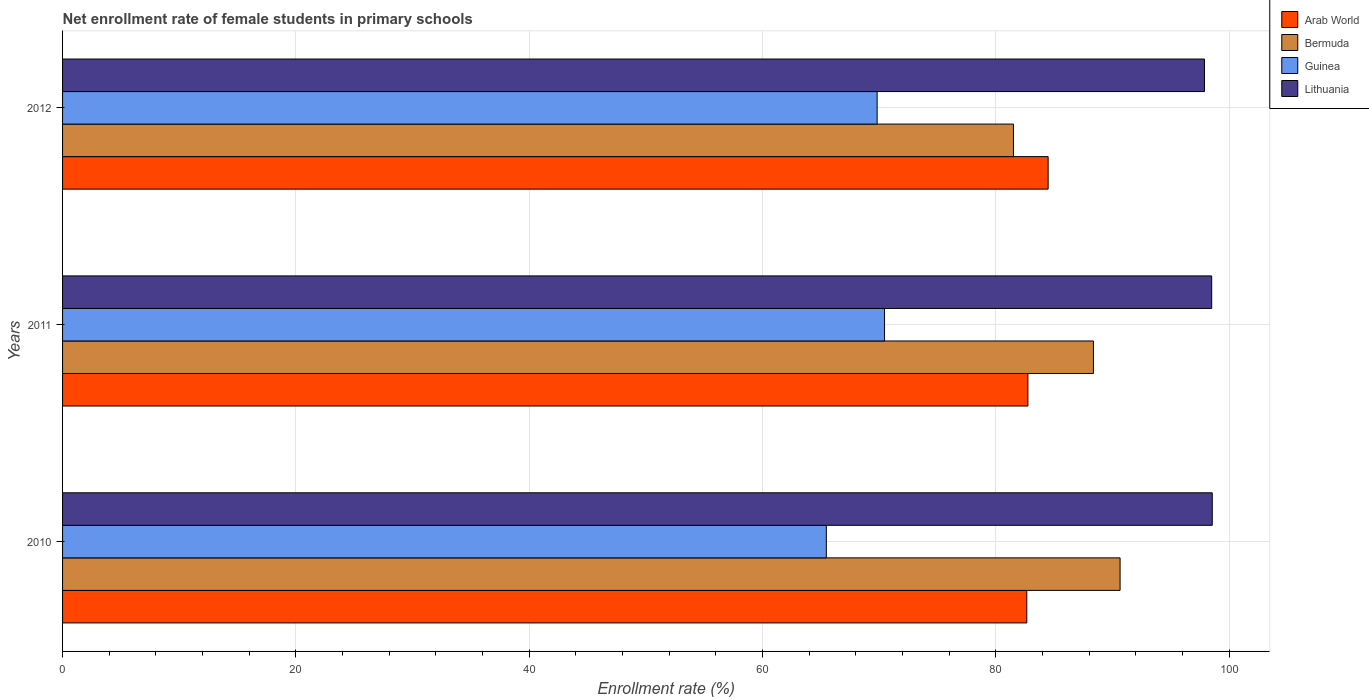In how many cases, is the number of bars for a given year not equal to the number of legend labels?
Your answer should be compact. 0. What is the net enrollment rate of female students in primary schools in Guinea in 2012?
Make the answer very short. 69.82. Across all years, what is the maximum net enrollment rate of female students in primary schools in Bermuda?
Provide a succinct answer. 90.64. Across all years, what is the minimum net enrollment rate of female students in primary schools in Guinea?
Your answer should be compact. 65.46. In which year was the net enrollment rate of female students in primary schools in Lithuania maximum?
Offer a very short reply. 2010. What is the total net enrollment rate of female students in primary schools in Arab World in the graph?
Keep it short and to the point. 249.86. What is the difference between the net enrollment rate of female students in primary schools in Lithuania in 2011 and that in 2012?
Provide a succinct answer. 0.62. What is the difference between the net enrollment rate of female students in primary schools in Lithuania in 2010 and the net enrollment rate of female students in primary schools in Guinea in 2011?
Your answer should be compact. 28.09. What is the average net enrollment rate of female students in primary schools in Arab World per year?
Provide a short and direct response. 83.29. In the year 2010, what is the difference between the net enrollment rate of female students in primary schools in Bermuda and net enrollment rate of female students in primary schools in Guinea?
Your response must be concise. 25.18. In how many years, is the net enrollment rate of female students in primary schools in Arab World greater than 60 %?
Keep it short and to the point. 3. What is the ratio of the net enrollment rate of female students in primary schools in Lithuania in 2011 to that in 2012?
Make the answer very short. 1.01. What is the difference between the highest and the second highest net enrollment rate of female students in primary schools in Arab World?
Your response must be concise. 1.73. What is the difference between the highest and the lowest net enrollment rate of female students in primary schools in Lithuania?
Provide a short and direct response. 0.67. Is the sum of the net enrollment rate of female students in primary schools in Lithuania in 2011 and 2012 greater than the maximum net enrollment rate of female students in primary schools in Arab World across all years?
Ensure brevity in your answer.  Yes. What does the 1st bar from the top in 2012 represents?
Offer a terse response. Lithuania. What does the 4th bar from the bottom in 2010 represents?
Give a very brief answer. Lithuania. Is it the case that in every year, the sum of the net enrollment rate of female students in primary schools in Arab World and net enrollment rate of female students in primary schools in Guinea is greater than the net enrollment rate of female students in primary schools in Bermuda?
Offer a very short reply. Yes. What is the difference between two consecutive major ticks on the X-axis?
Make the answer very short. 20. Does the graph contain any zero values?
Offer a terse response. No. Where does the legend appear in the graph?
Offer a very short reply. Top right. How are the legend labels stacked?
Your answer should be compact. Vertical. What is the title of the graph?
Make the answer very short. Net enrollment rate of female students in primary schools. What is the label or title of the X-axis?
Ensure brevity in your answer.  Enrollment rate (%). What is the label or title of the Y-axis?
Keep it short and to the point. Years. What is the Enrollment rate (%) of Arab World in 2010?
Your answer should be very brief. 82.65. What is the Enrollment rate (%) of Bermuda in 2010?
Ensure brevity in your answer.  90.64. What is the Enrollment rate (%) of Guinea in 2010?
Your answer should be very brief. 65.46. What is the Enrollment rate (%) of Lithuania in 2010?
Offer a terse response. 98.54. What is the Enrollment rate (%) in Arab World in 2011?
Provide a short and direct response. 82.74. What is the Enrollment rate (%) in Bermuda in 2011?
Your response must be concise. 88.36. What is the Enrollment rate (%) of Guinea in 2011?
Make the answer very short. 70.45. What is the Enrollment rate (%) of Lithuania in 2011?
Provide a succinct answer. 98.49. What is the Enrollment rate (%) of Arab World in 2012?
Provide a succinct answer. 84.48. What is the Enrollment rate (%) of Bermuda in 2012?
Ensure brevity in your answer.  81.5. What is the Enrollment rate (%) in Guinea in 2012?
Give a very brief answer. 69.82. What is the Enrollment rate (%) in Lithuania in 2012?
Give a very brief answer. 97.88. Across all years, what is the maximum Enrollment rate (%) of Arab World?
Ensure brevity in your answer.  84.48. Across all years, what is the maximum Enrollment rate (%) of Bermuda?
Provide a short and direct response. 90.64. Across all years, what is the maximum Enrollment rate (%) in Guinea?
Offer a very short reply. 70.45. Across all years, what is the maximum Enrollment rate (%) in Lithuania?
Your response must be concise. 98.54. Across all years, what is the minimum Enrollment rate (%) of Arab World?
Give a very brief answer. 82.65. Across all years, what is the minimum Enrollment rate (%) of Bermuda?
Ensure brevity in your answer.  81.5. Across all years, what is the minimum Enrollment rate (%) in Guinea?
Keep it short and to the point. 65.46. Across all years, what is the minimum Enrollment rate (%) of Lithuania?
Ensure brevity in your answer.  97.88. What is the total Enrollment rate (%) in Arab World in the graph?
Ensure brevity in your answer.  249.86. What is the total Enrollment rate (%) of Bermuda in the graph?
Offer a very short reply. 260.5. What is the total Enrollment rate (%) in Guinea in the graph?
Your answer should be compact. 205.73. What is the total Enrollment rate (%) in Lithuania in the graph?
Offer a terse response. 294.91. What is the difference between the Enrollment rate (%) in Arab World in 2010 and that in 2011?
Give a very brief answer. -0.09. What is the difference between the Enrollment rate (%) of Bermuda in 2010 and that in 2011?
Offer a very short reply. 2.29. What is the difference between the Enrollment rate (%) of Guinea in 2010 and that in 2011?
Your answer should be very brief. -4.99. What is the difference between the Enrollment rate (%) in Lithuania in 2010 and that in 2011?
Offer a terse response. 0.05. What is the difference between the Enrollment rate (%) of Arab World in 2010 and that in 2012?
Offer a terse response. -1.83. What is the difference between the Enrollment rate (%) of Bermuda in 2010 and that in 2012?
Provide a succinct answer. 9.14. What is the difference between the Enrollment rate (%) of Guinea in 2010 and that in 2012?
Offer a terse response. -4.36. What is the difference between the Enrollment rate (%) in Lithuania in 2010 and that in 2012?
Give a very brief answer. 0.67. What is the difference between the Enrollment rate (%) in Arab World in 2011 and that in 2012?
Your answer should be compact. -1.73. What is the difference between the Enrollment rate (%) in Bermuda in 2011 and that in 2012?
Your answer should be compact. 6.85. What is the difference between the Enrollment rate (%) of Guinea in 2011 and that in 2012?
Your answer should be very brief. 0.63. What is the difference between the Enrollment rate (%) of Lithuania in 2011 and that in 2012?
Your answer should be very brief. 0.62. What is the difference between the Enrollment rate (%) of Arab World in 2010 and the Enrollment rate (%) of Bermuda in 2011?
Make the answer very short. -5.71. What is the difference between the Enrollment rate (%) in Arab World in 2010 and the Enrollment rate (%) in Guinea in 2011?
Make the answer very short. 12.19. What is the difference between the Enrollment rate (%) of Arab World in 2010 and the Enrollment rate (%) of Lithuania in 2011?
Make the answer very short. -15.85. What is the difference between the Enrollment rate (%) of Bermuda in 2010 and the Enrollment rate (%) of Guinea in 2011?
Your answer should be very brief. 20.19. What is the difference between the Enrollment rate (%) in Bermuda in 2010 and the Enrollment rate (%) in Lithuania in 2011?
Your answer should be compact. -7.85. What is the difference between the Enrollment rate (%) in Guinea in 2010 and the Enrollment rate (%) in Lithuania in 2011?
Make the answer very short. -33.03. What is the difference between the Enrollment rate (%) of Arab World in 2010 and the Enrollment rate (%) of Bermuda in 2012?
Give a very brief answer. 1.14. What is the difference between the Enrollment rate (%) of Arab World in 2010 and the Enrollment rate (%) of Guinea in 2012?
Provide a short and direct response. 12.83. What is the difference between the Enrollment rate (%) in Arab World in 2010 and the Enrollment rate (%) in Lithuania in 2012?
Ensure brevity in your answer.  -15.23. What is the difference between the Enrollment rate (%) in Bermuda in 2010 and the Enrollment rate (%) in Guinea in 2012?
Give a very brief answer. 20.82. What is the difference between the Enrollment rate (%) of Bermuda in 2010 and the Enrollment rate (%) of Lithuania in 2012?
Your answer should be compact. -7.24. What is the difference between the Enrollment rate (%) of Guinea in 2010 and the Enrollment rate (%) of Lithuania in 2012?
Your response must be concise. -32.41. What is the difference between the Enrollment rate (%) in Arab World in 2011 and the Enrollment rate (%) in Bermuda in 2012?
Your answer should be very brief. 1.24. What is the difference between the Enrollment rate (%) of Arab World in 2011 and the Enrollment rate (%) of Guinea in 2012?
Make the answer very short. 12.92. What is the difference between the Enrollment rate (%) in Arab World in 2011 and the Enrollment rate (%) in Lithuania in 2012?
Keep it short and to the point. -15.14. What is the difference between the Enrollment rate (%) of Bermuda in 2011 and the Enrollment rate (%) of Guinea in 2012?
Offer a very short reply. 18.54. What is the difference between the Enrollment rate (%) in Bermuda in 2011 and the Enrollment rate (%) in Lithuania in 2012?
Give a very brief answer. -9.52. What is the difference between the Enrollment rate (%) in Guinea in 2011 and the Enrollment rate (%) in Lithuania in 2012?
Your response must be concise. -27.43. What is the average Enrollment rate (%) in Arab World per year?
Keep it short and to the point. 83.29. What is the average Enrollment rate (%) of Bermuda per year?
Your response must be concise. 86.83. What is the average Enrollment rate (%) in Guinea per year?
Give a very brief answer. 68.58. What is the average Enrollment rate (%) in Lithuania per year?
Your answer should be very brief. 98.3. In the year 2010, what is the difference between the Enrollment rate (%) of Arab World and Enrollment rate (%) of Bermuda?
Ensure brevity in your answer.  -8. In the year 2010, what is the difference between the Enrollment rate (%) of Arab World and Enrollment rate (%) of Guinea?
Your response must be concise. 17.18. In the year 2010, what is the difference between the Enrollment rate (%) of Arab World and Enrollment rate (%) of Lithuania?
Make the answer very short. -15.9. In the year 2010, what is the difference between the Enrollment rate (%) of Bermuda and Enrollment rate (%) of Guinea?
Keep it short and to the point. 25.18. In the year 2010, what is the difference between the Enrollment rate (%) of Bermuda and Enrollment rate (%) of Lithuania?
Give a very brief answer. -7.9. In the year 2010, what is the difference between the Enrollment rate (%) of Guinea and Enrollment rate (%) of Lithuania?
Offer a very short reply. -33.08. In the year 2011, what is the difference between the Enrollment rate (%) of Arab World and Enrollment rate (%) of Bermuda?
Give a very brief answer. -5.62. In the year 2011, what is the difference between the Enrollment rate (%) of Arab World and Enrollment rate (%) of Guinea?
Offer a terse response. 12.29. In the year 2011, what is the difference between the Enrollment rate (%) of Arab World and Enrollment rate (%) of Lithuania?
Offer a very short reply. -15.75. In the year 2011, what is the difference between the Enrollment rate (%) of Bermuda and Enrollment rate (%) of Guinea?
Your answer should be very brief. 17.9. In the year 2011, what is the difference between the Enrollment rate (%) in Bermuda and Enrollment rate (%) in Lithuania?
Your answer should be very brief. -10.14. In the year 2011, what is the difference between the Enrollment rate (%) of Guinea and Enrollment rate (%) of Lithuania?
Your answer should be compact. -28.04. In the year 2012, what is the difference between the Enrollment rate (%) of Arab World and Enrollment rate (%) of Bermuda?
Make the answer very short. 2.97. In the year 2012, what is the difference between the Enrollment rate (%) of Arab World and Enrollment rate (%) of Guinea?
Your answer should be very brief. 14.66. In the year 2012, what is the difference between the Enrollment rate (%) of Arab World and Enrollment rate (%) of Lithuania?
Make the answer very short. -13.4. In the year 2012, what is the difference between the Enrollment rate (%) in Bermuda and Enrollment rate (%) in Guinea?
Offer a terse response. 11.68. In the year 2012, what is the difference between the Enrollment rate (%) of Bermuda and Enrollment rate (%) of Lithuania?
Ensure brevity in your answer.  -16.37. In the year 2012, what is the difference between the Enrollment rate (%) in Guinea and Enrollment rate (%) in Lithuania?
Offer a terse response. -28.06. What is the ratio of the Enrollment rate (%) in Bermuda in 2010 to that in 2011?
Make the answer very short. 1.03. What is the ratio of the Enrollment rate (%) of Guinea in 2010 to that in 2011?
Give a very brief answer. 0.93. What is the ratio of the Enrollment rate (%) in Lithuania in 2010 to that in 2011?
Make the answer very short. 1. What is the ratio of the Enrollment rate (%) of Arab World in 2010 to that in 2012?
Offer a terse response. 0.98. What is the ratio of the Enrollment rate (%) of Bermuda in 2010 to that in 2012?
Provide a succinct answer. 1.11. What is the ratio of the Enrollment rate (%) in Guinea in 2010 to that in 2012?
Offer a very short reply. 0.94. What is the ratio of the Enrollment rate (%) in Lithuania in 2010 to that in 2012?
Give a very brief answer. 1.01. What is the ratio of the Enrollment rate (%) of Arab World in 2011 to that in 2012?
Give a very brief answer. 0.98. What is the ratio of the Enrollment rate (%) in Bermuda in 2011 to that in 2012?
Give a very brief answer. 1.08. What is the ratio of the Enrollment rate (%) in Guinea in 2011 to that in 2012?
Make the answer very short. 1.01. What is the difference between the highest and the second highest Enrollment rate (%) in Arab World?
Provide a succinct answer. 1.73. What is the difference between the highest and the second highest Enrollment rate (%) in Bermuda?
Your answer should be compact. 2.29. What is the difference between the highest and the second highest Enrollment rate (%) in Guinea?
Make the answer very short. 0.63. What is the difference between the highest and the second highest Enrollment rate (%) in Lithuania?
Offer a very short reply. 0.05. What is the difference between the highest and the lowest Enrollment rate (%) in Arab World?
Ensure brevity in your answer.  1.83. What is the difference between the highest and the lowest Enrollment rate (%) in Bermuda?
Offer a terse response. 9.14. What is the difference between the highest and the lowest Enrollment rate (%) of Guinea?
Make the answer very short. 4.99. What is the difference between the highest and the lowest Enrollment rate (%) in Lithuania?
Your answer should be compact. 0.67. 